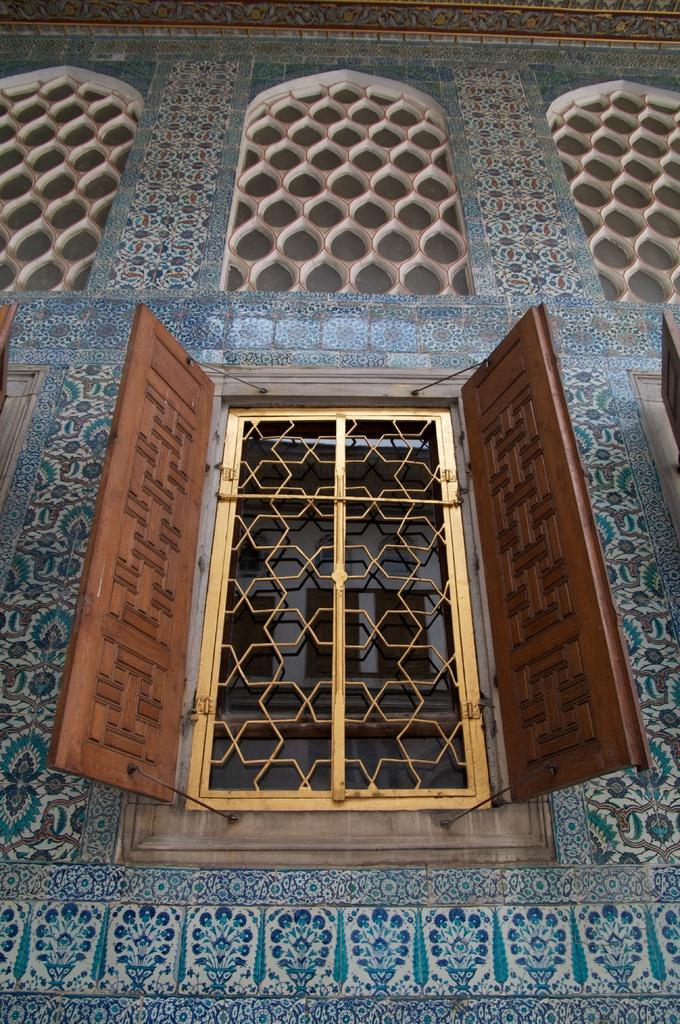What is the main structure in the center of the image? There is a building in the center of the image. What can be seen on the sides of the building? There is a wall in the image. Is there any opening in the wall? Yes, there is a window in the image. What type of lighting is present in the image? There is a tube light in the image. Are there any other objects visible in the image? Yes, there are other objects in the image. Can you describe the design on the building? There is a design on the building, but the specifics are not mentioned in the facts. How many yaks are visible in the image? There are no yaks present in the image. What message of peace can be seen on the building? There is no message of peace visible on the building in the image. 